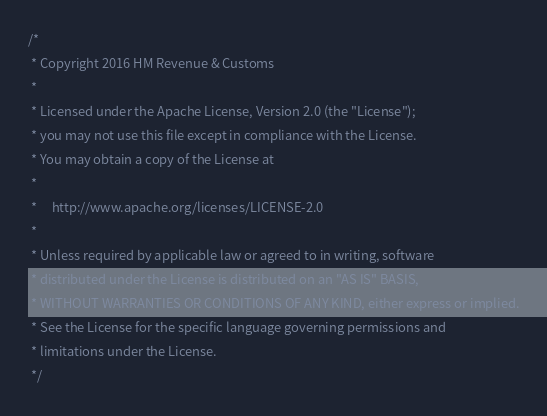<code> <loc_0><loc_0><loc_500><loc_500><_Scala_>/*
 * Copyright 2016 HM Revenue & Customs
 *
 * Licensed under the Apache License, Version 2.0 (the "License");
 * you may not use this file except in compliance with the License.
 * You may obtain a copy of the License at
 *
 *     http://www.apache.org/licenses/LICENSE-2.0
 *
 * Unless required by applicable law or agreed to in writing, software
 * distributed under the License is distributed on an "AS IS" BASIS,
 * WITHOUT WARRANTIES OR CONDITIONS OF ANY KIND, either express or implied.
 * See the License for the specific language governing permissions and
 * limitations under the License.
 */
</code> 